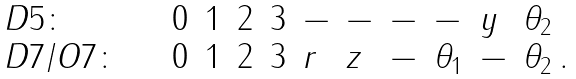<formula> <loc_0><loc_0><loc_500><loc_500>\begin{array} { l l l l l l l l l l l } D 5 \colon \quad & 0 & 1 & 2 & 3 & - & - & - & - & y & \theta _ { 2 } \\ D 7 / O 7 \colon \quad & 0 & 1 & 2 & 3 & r & z & - & \theta _ { 1 } & - & \theta _ { 2 } \, . \end{array}</formula> 